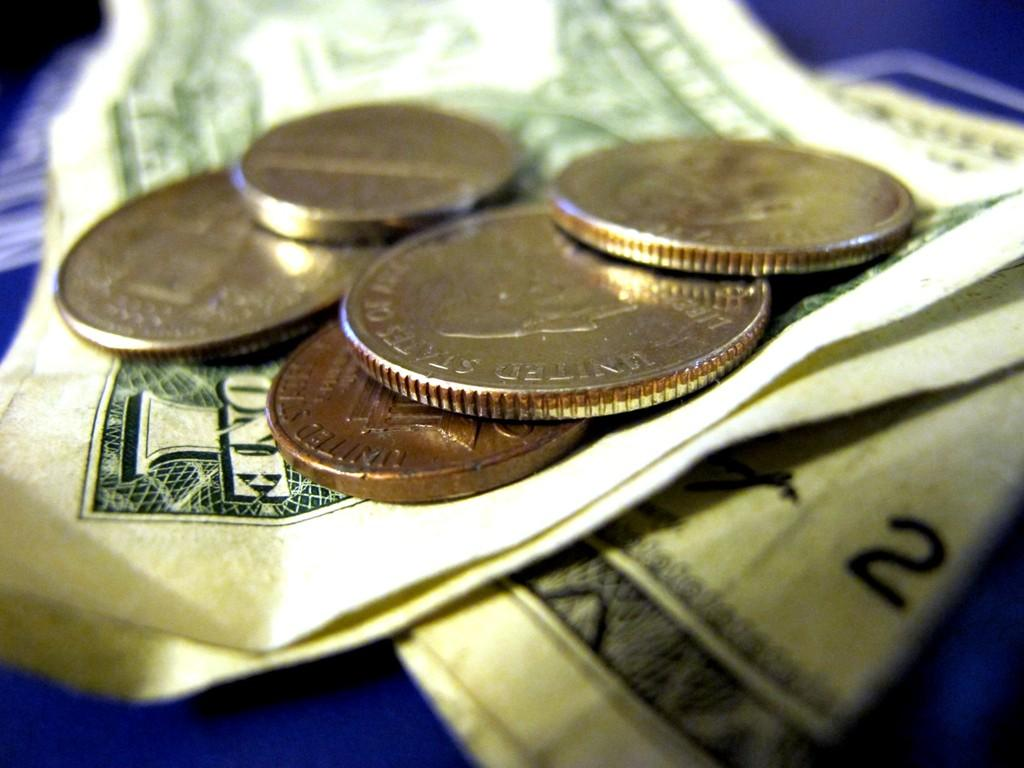<image>
Present a compact description of the photo's key features. coins on top of a dollar bill that say united states of america on them 